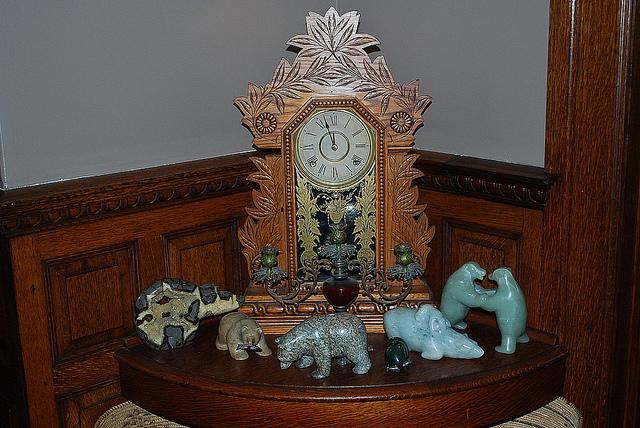What material are the two bears to the right of the desk clock made from?

Choices:
A) glass
B) plastic
C) jade
D) ceramic jade 